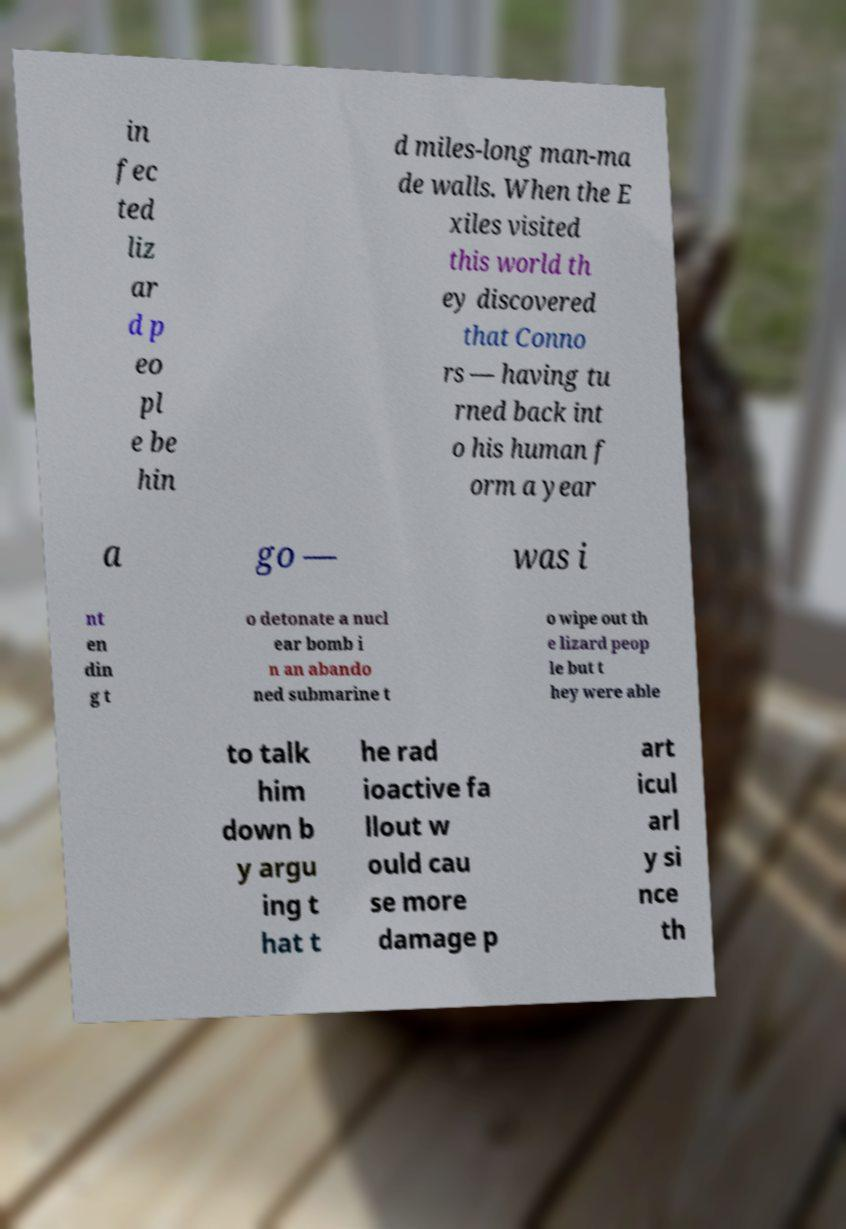Could you extract and type out the text from this image? in fec ted liz ar d p eo pl e be hin d miles-long man-ma de walls. When the E xiles visited this world th ey discovered that Conno rs — having tu rned back int o his human f orm a year a go — was i nt en din g t o detonate a nucl ear bomb i n an abando ned submarine t o wipe out th e lizard peop le but t hey were able to talk him down b y argu ing t hat t he rad ioactive fa llout w ould cau se more damage p art icul arl y si nce th 